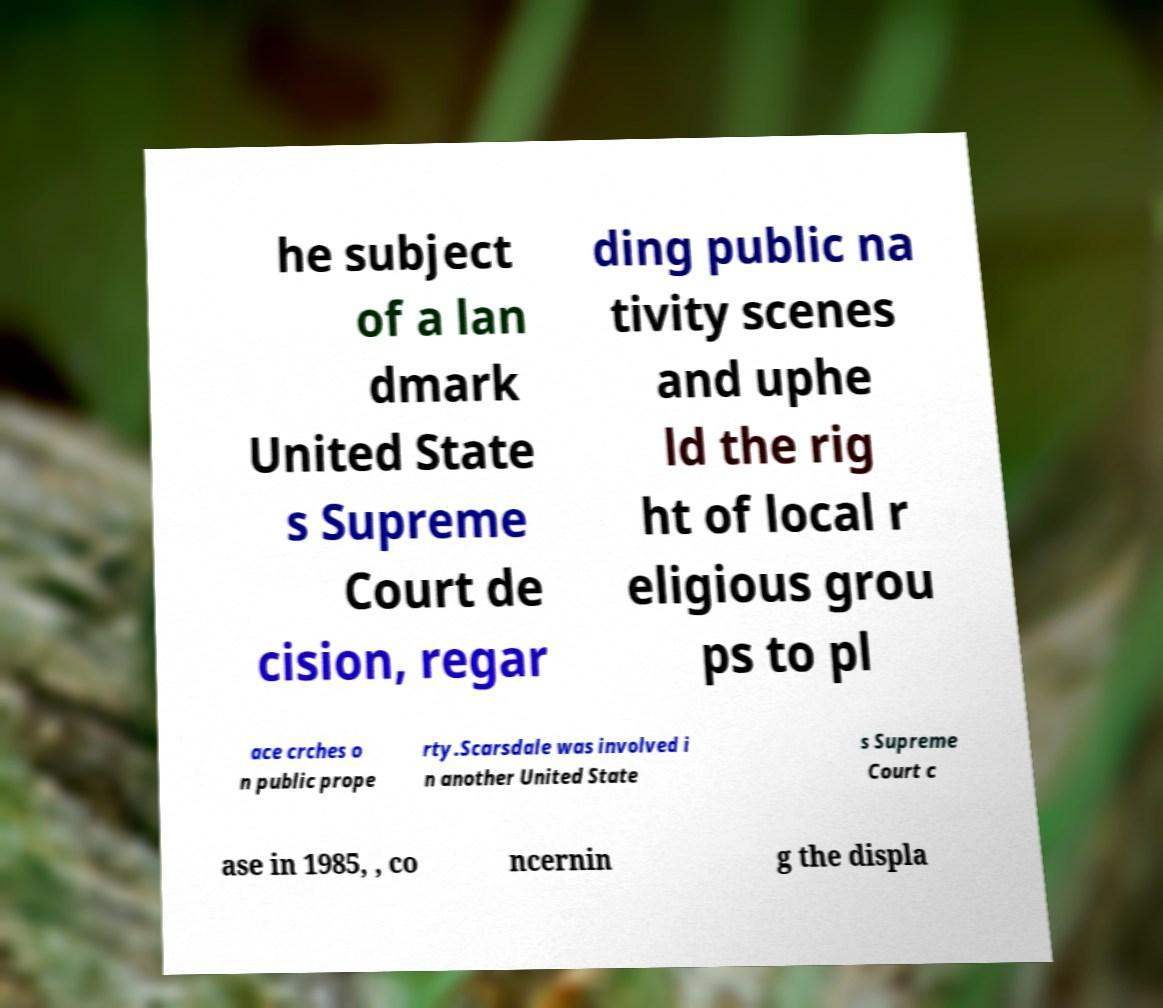Could you assist in decoding the text presented in this image and type it out clearly? he subject of a lan dmark United State s Supreme Court de cision, regar ding public na tivity scenes and uphe ld the rig ht of local r eligious grou ps to pl ace crches o n public prope rty.Scarsdale was involved i n another United State s Supreme Court c ase in 1985, , co ncernin g the displa 